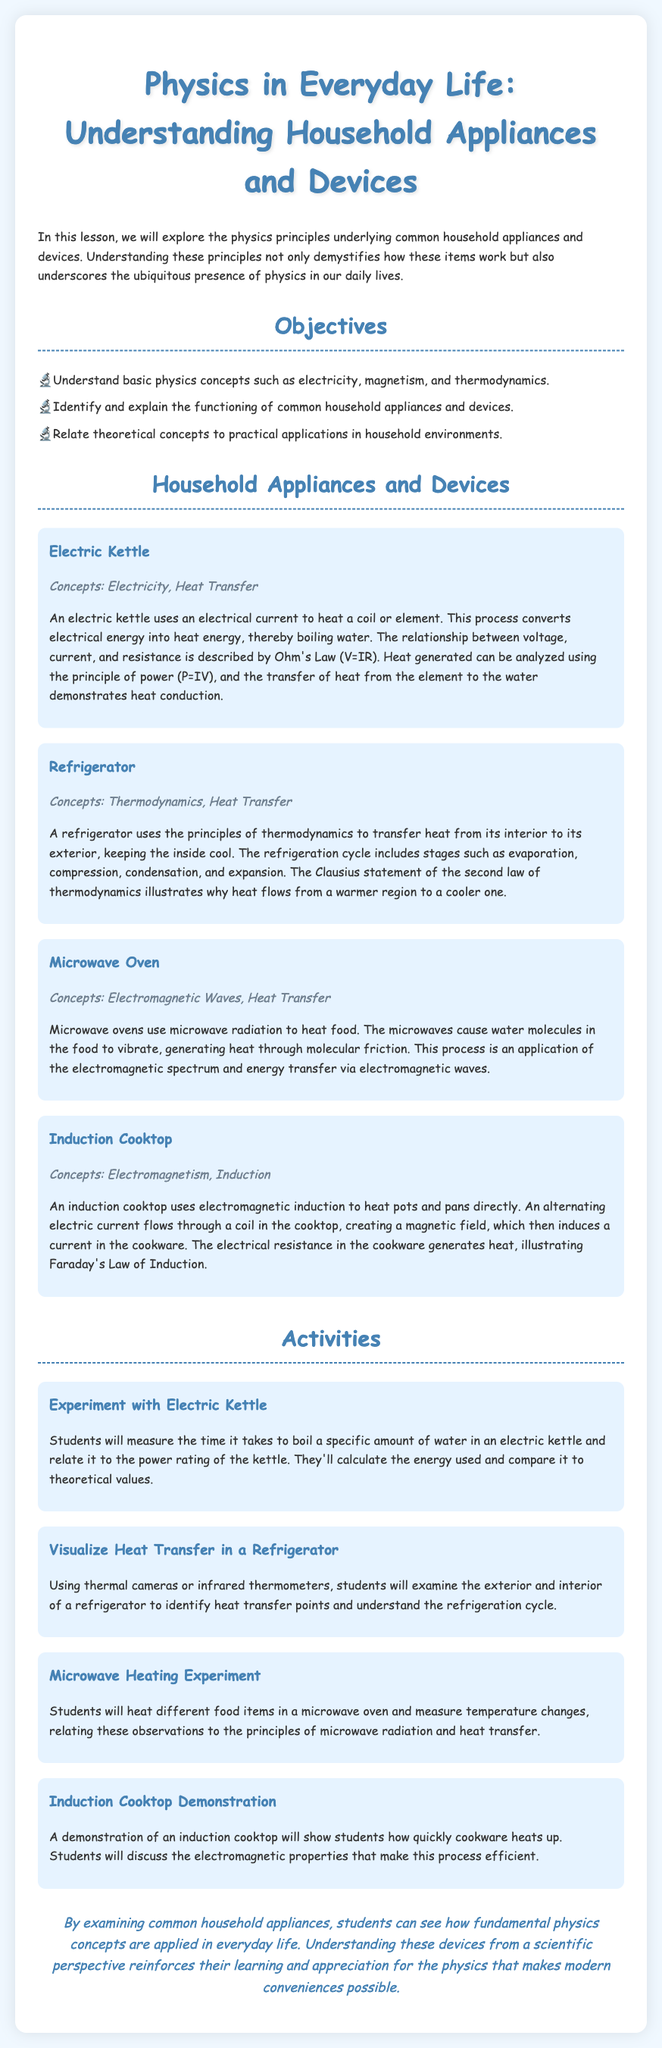what is the title of the lesson plan? The title is mentioned at the beginning of the document, encapsulating the main theme of the lesson.
Answer: Physics in Everyday Life: Understanding Household Appliances and Devices what principle does an electric kettle primarily illustrate? The electric kettle uses an electrical current to heat a coil, effectively demonstrating the conversion of energy, and is related to electricity and heat transfer.
Answer: Electricity, Heat Transfer how many objectives are listed in the lesson plan? The document clearly states the number of objectives outlined for the lesson.
Answer: three what process do microwaves use to heat food? The document describes how microwaves cause water molecules in food to vibrate, generating heat through molecular friction.
Answer: Microwave radiation which law is illustrated by the induction cooktop? The induction cooktop demonstration shows the principle of induced current via a magnetic field, which relates to a specific law in electromagnetism.
Answer: Faraday's Law of Induction what activity involves measuring temperature changes in food items? The activity listed under the microwave section specifies that students will measure temperature changes, connecting it to principles of heat transfer.
Answer: Microwave Heating Experiment what is the conclusion about understanding household appliances? The final thoughts in the document summarize the significance of applying physics in real-life scenarios.
Answer: Reinforces learning and appreciation for physics which household device is associated with the refrigeration cycle? The refrigerator is specifically described as using a cycle that includes evaporation, compression, condensation, and expansion to keep areas cool.
Answer: Refrigerator 